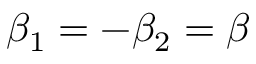<formula> <loc_0><loc_0><loc_500><loc_500>\beta _ { 1 } = - \beta _ { 2 } = \beta</formula> 